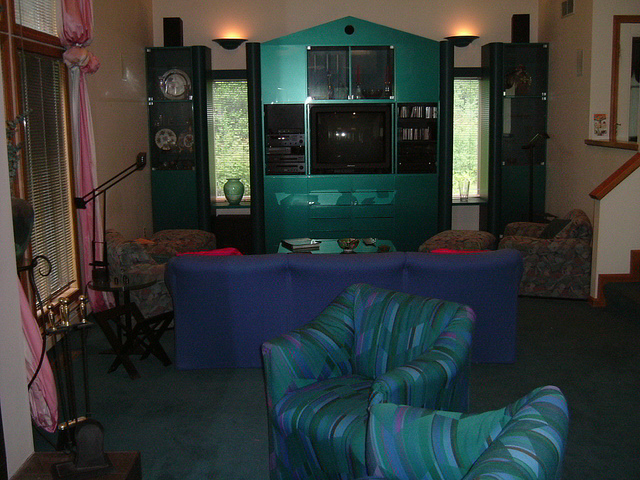<image>What is it so dark in this room? It is unknown why it is so dark in the room. It could be due to dim lights or the blinds being closed. What is it so dark in this room? I don't know why it is so dark in this room. There are several possible reasons such as dim lights, closed drapes, and dark carpet and furniture. 